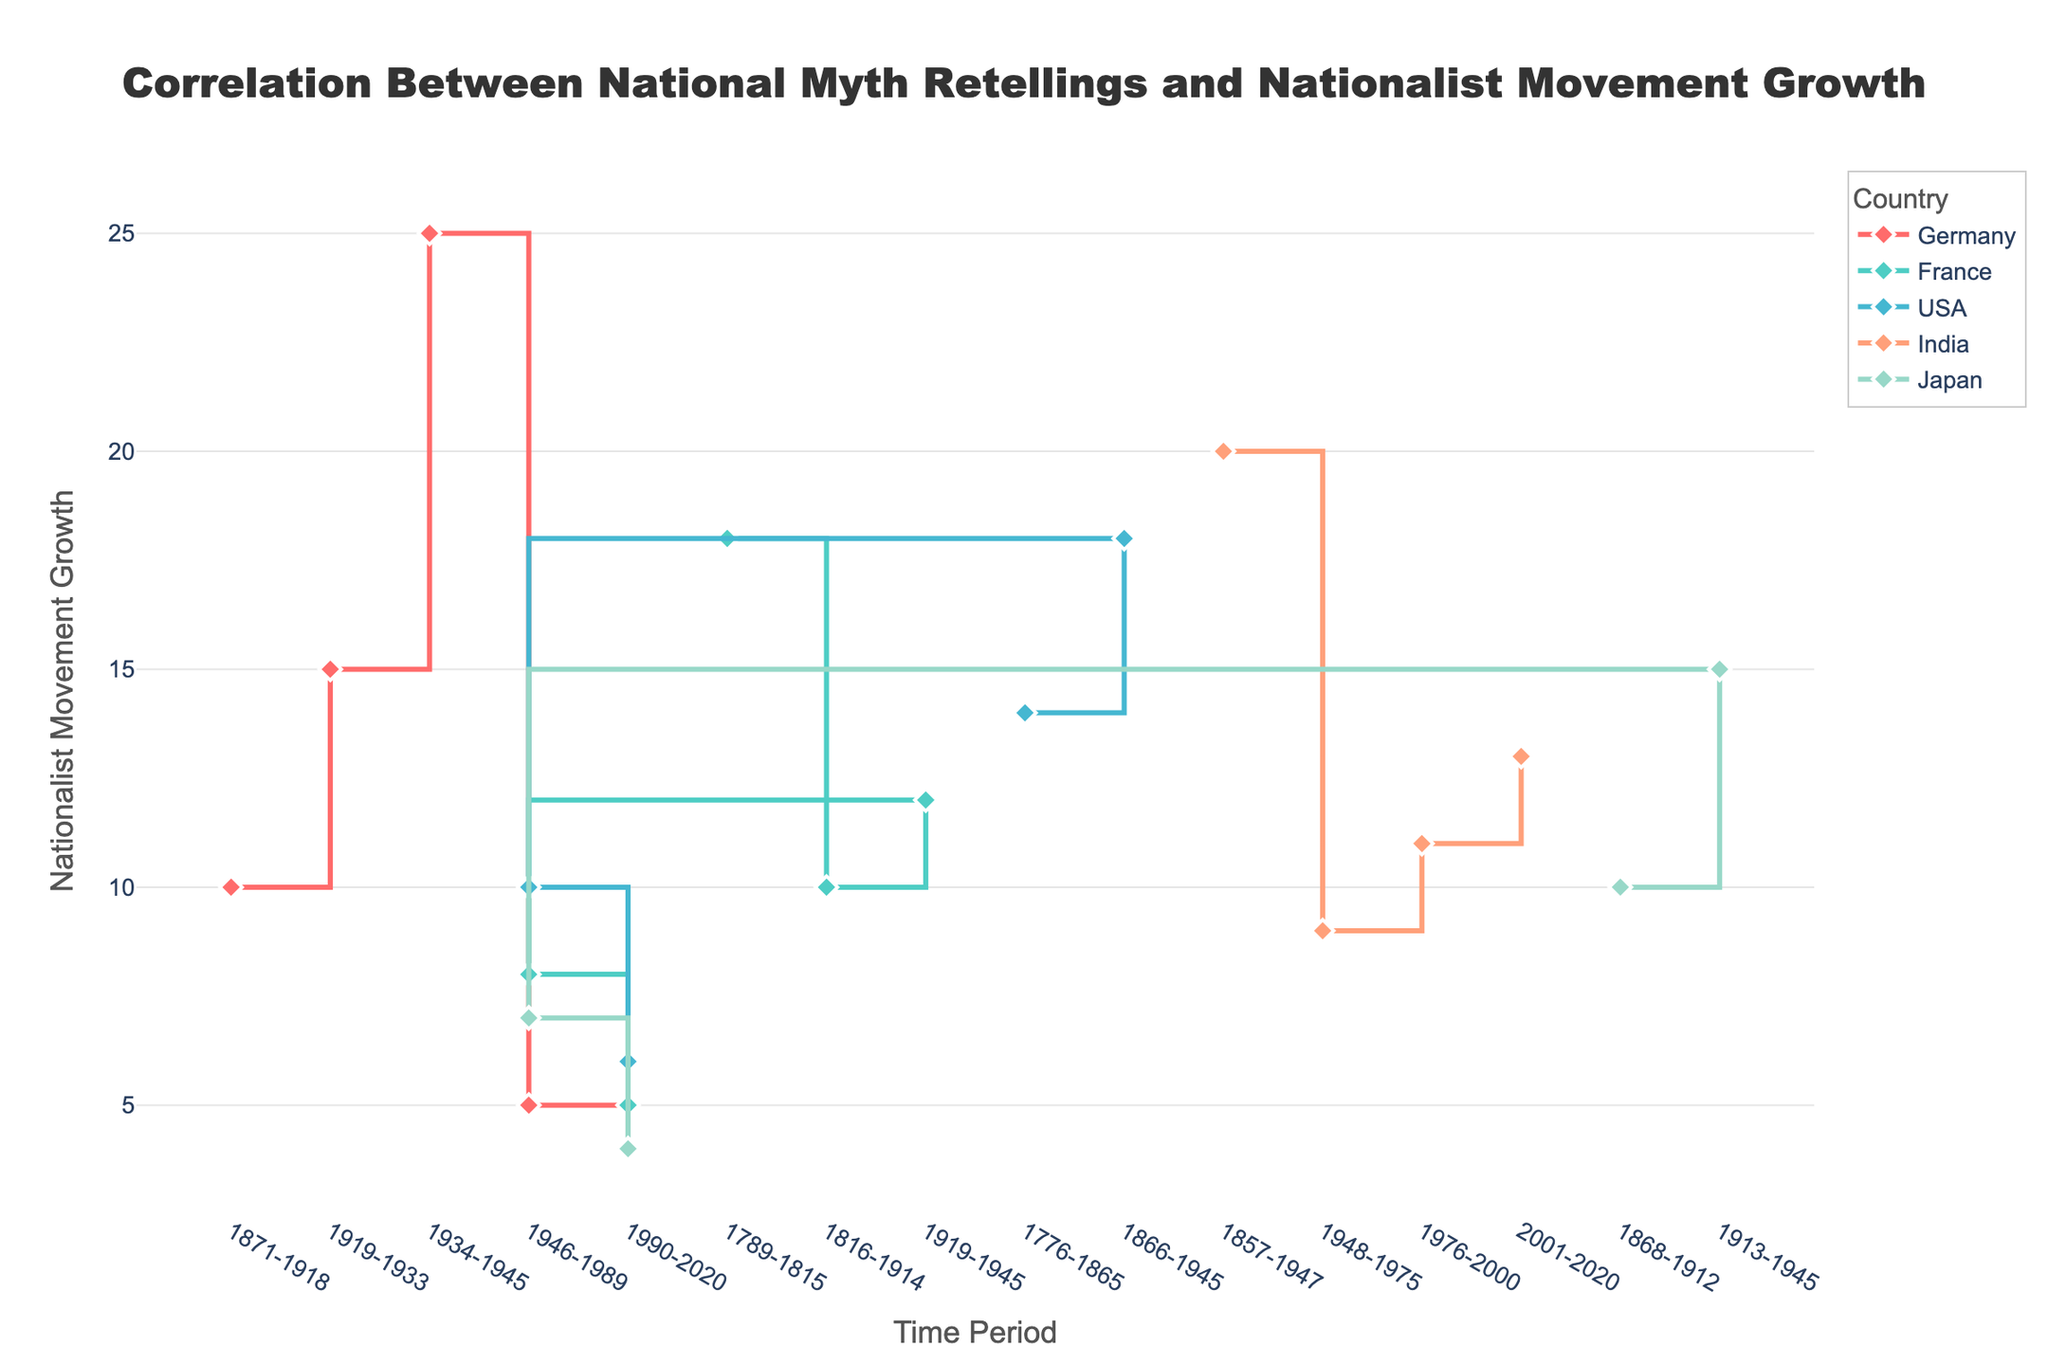What is the title of the plot? The title is prominent and located at the top center of the plot. It reads, "Correlation Between National Myth Retellings and Nationalist Movement Growth."
Answer: Correlation Between National Myth Retellings and Nationalist Movement Growth How many time periods are represented for each country? By inspecting the x-axis, which shows the time periods, and observing the lines for each country, we can see that each country has lines spanning across multiple distinct periods. Each country (Germany, France, USA, India, Japan) has data spanning about 4-5 periods.
Answer: 4-5 Which country had the highest peak in nationalist movement growth? By examining the y-axis values across all lines, Germany during the period 1934-1945 shows the highest peak with a growth value of 25.
Answer: Germany During which period did France have the most significant increase in nationalist movement growth? By tracing France's line graph and noting the growth changes, we observe the sharpest increase between the period 1789-1815 with growth from 0 to 18.
Answer: 1789-1815 What is the relationship between the number of national myth retellings and nationalist movement growth for India from 1857-1947? The plot shows India’s data point with '8' retellings and corresponding '20' growth during this period, highlighting a positive correlation between the two metrics.
Answer: Positive correlation What's the average nationalist movement growth for the USA over all periods? Calculate the average by summing the nationalist movement growth values for all periods (14 + 18 + 10 + 6 = 48) and then dividing by the number of periods (which is 4). Therefore, the average is 48 / 4 = 12.
Answer: 12 Which country had the smallest fluctuation in nationalist movement growth over time? By comparing the variation in the heights of each country's line, we see that Japan’s line shows the smallest range of values from 4 to 15.
Answer: Japan Between Germany and France, which country saw a decline in nationalist movement growth after 1945, and by how much did it decline? After 1945, observe the declining segments for Germany and France. Germany's growth decreased from 25 to 5 (decline of 20) and France's from 12 to 8 (decline of 4). Clearly, Germany had the more significant decline.
Answer: Germany, by 20 Which periods show the lowest nationalist movement growth for Germany and Japan, respectively? Observe the lowest y-axis value for each country's line. For Germany, it's 1990-2020 with growth at 4, and for Japan, it's also 1990-2020 with growth at 4.
Answer: Germany: 1990-2020, Japan: 1990-2020 